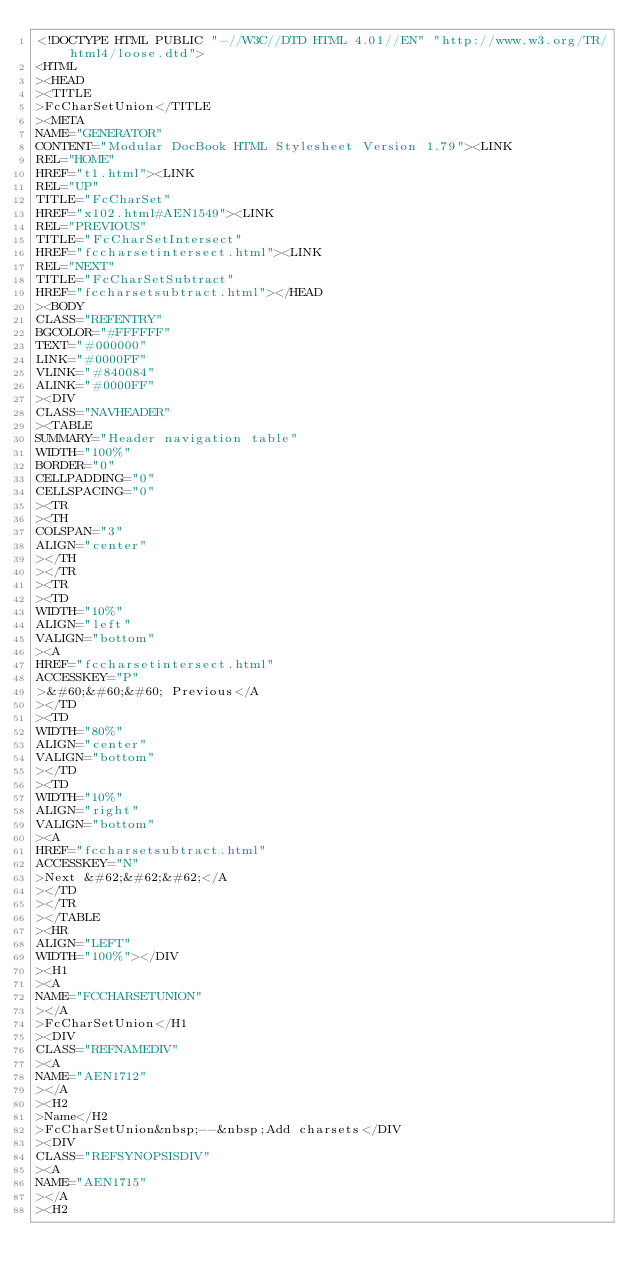Convert code to text. <code><loc_0><loc_0><loc_500><loc_500><_HTML_><!DOCTYPE HTML PUBLIC "-//W3C//DTD HTML 4.01//EN" "http://www.w3.org/TR/html4/loose.dtd">
<HTML
><HEAD
><TITLE
>FcCharSetUnion</TITLE
><META
NAME="GENERATOR"
CONTENT="Modular DocBook HTML Stylesheet Version 1.79"><LINK
REL="HOME"
HREF="t1.html"><LINK
REL="UP"
TITLE="FcCharSet"
HREF="x102.html#AEN1549"><LINK
REL="PREVIOUS"
TITLE="FcCharSetIntersect"
HREF="fccharsetintersect.html"><LINK
REL="NEXT"
TITLE="FcCharSetSubtract"
HREF="fccharsetsubtract.html"></HEAD
><BODY
CLASS="REFENTRY"
BGCOLOR="#FFFFFF"
TEXT="#000000"
LINK="#0000FF"
VLINK="#840084"
ALINK="#0000FF"
><DIV
CLASS="NAVHEADER"
><TABLE
SUMMARY="Header navigation table"
WIDTH="100%"
BORDER="0"
CELLPADDING="0"
CELLSPACING="0"
><TR
><TH
COLSPAN="3"
ALIGN="center"
></TH
></TR
><TR
><TD
WIDTH="10%"
ALIGN="left"
VALIGN="bottom"
><A
HREF="fccharsetintersect.html"
ACCESSKEY="P"
>&#60;&#60;&#60; Previous</A
></TD
><TD
WIDTH="80%"
ALIGN="center"
VALIGN="bottom"
></TD
><TD
WIDTH="10%"
ALIGN="right"
VALIGN="bottom"
><A
HREF="fccharsetsubtract.html"
ACCESSKEY="N"
>Next &#62;&#62;&#62;</A
></TD
></TR
></TABLE
><HR
ALIGN="LEFT"
WIDTH="100%"></DIV
><H1
><A
NAME="FCCHARSETUNION"
></A
>FcCharSetUnion</H1
><DIV
CLASS="REFNAMEDIV"
><A
NAME="AEN1712"
></A
><H2
>Name</H2
>FcCharSetUnion&nbsp;--&nbsp;Add charsets</DIV
><DIV
CLASS="REFSYNOPSISDIV"
><A
NAME="AEN1715"
></A
><H2</code> 